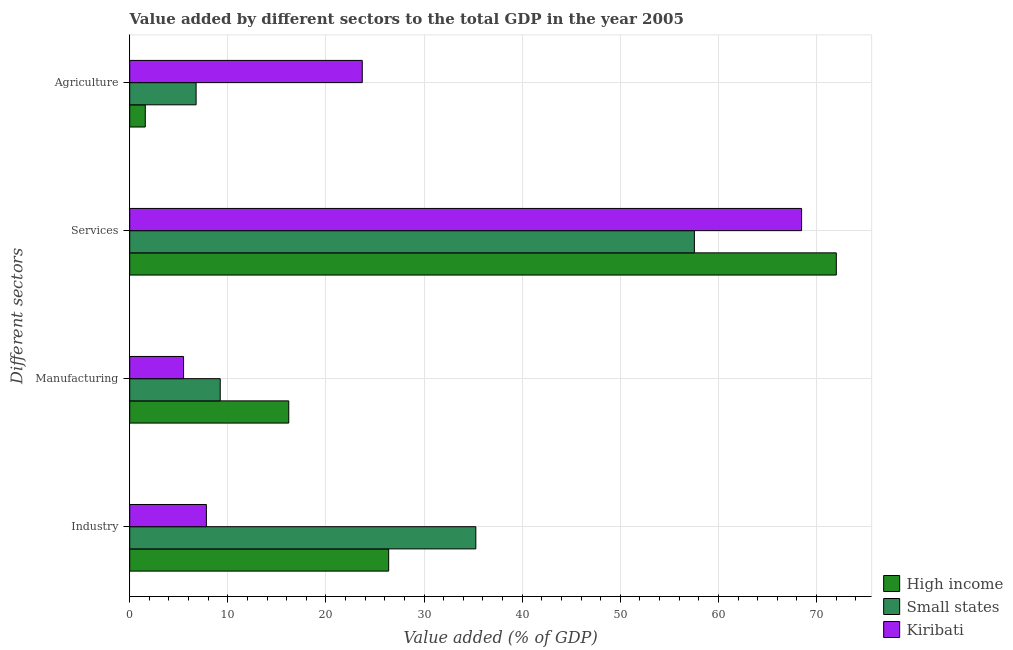How many different coloured bars are there?
Keep it short and to the point. 3. How many bars are there on the 3rd tick from the top?
Your response must be concise. 3. What is the label of the 1st group of bars from the top?
Make the answer very short. Agriculture. What is the value added by agricultural sector in Small states?
Give a very brief answer. 6.77. Across all countries, what is the maximum value added by industrial sector?
Keep it short and to the point. 35.28. Across all countries, what is the minimum value added by manufacturing sector?
Ensure brevity in your answer.  5.49. In which country was the value added by services sector maximum?
Give a very brief answer. High income. In which country was the value added by services sector minimum?
Provide a short and direct response. Small states. What is the total value added by agricultural sector in the graph?
Provide a succinct answer. 32.05. What is the difference between the value added by services sector in Kiribati and that in High income?
Your answer should be compact. -3.54. What is the difference between the value added by agricultural sector in Kiribati and the value added by services sector in High income?
Provide a succinct answer. -48.32. What is the average value added by industrial sector per country?
Provide a succinct answer. 23.16. What is the difference between the value added by services sector and value added by industrial sector in Kiribati?
Provide a short and direct response. 60.67. In how many countries, is the value added by services sector greater than 58 %?
Ensure brevity in your answer.  2. What is the ratio of the value added by industrial sector in Small states to that in Kiribati?
Offer a very short reply. 4.51. What is the difference between the highest and the second highest value added by services sector?
Make the answer very short. 3.54. What is the difference between the highest and the lowest value added by manufacturing sector?
Provide a succinct answer. 10.72. What does the 2nd bar from the top in Services represents?
Your answer should be compact. Small states. Is it the case that in every country, the sum of the value added by industrial sector and value added by manufacturing sector is greater than the value added by services sector?
Your answer should be very brief. No. How many bars are there?
Your answer should be very brief. 12. What is the difference between two consecutive major ticks on the X-axis?
Keep it short and to the point. 10. Does the graph contain grids?
Give a very brief answer. Yes. How many legend labels are there?
Your answer should be very brief. 3. What is the title of the graph?
Your answer should be compact. Value added by different sectors to the total GDP in the year 2005. Does "Ethiopia" appear as one of the legend labels in the graph?
Your answer should be very brief. No. What is the label or title of the X-axis?
Keep it short and to the point. Value added (% of GDP). What is the label or title of the Y-axis?
Keep it short and to the point. Different sectors. What is the Value added (% of GDP) in High income in Industry?
Provide a short and direct response. 26.39. What is the Value added (% of GDP) in Small states in Industry?
Provide a short and direct response. 35.28. What is the Value added (% of GDP) in Kiribati in Industry?
Your answer should be very brief. 7.81. What is the Value added (% of GDP) of High income in Manufacturing?
Your answer should be very brief. 16.21. What is the Value added (% of GDP) of Small states in Manufacturing?
Offer a terse response. 9.23. What is the Value added (% of GDP) in Kiribati in Manufacturing?
Your answer should be very brief. 5.49. What is the Value added (% of GDP) of High income in Services?
Your answer should be compact. 72.02. What is the Value added (% of GDP) in Small states in Services?
Offer a terse response. 57.55. What is the Value added (% of GDP) in Kiribati in Services?
Make the answer very short. 68.48. What is the Value added (% of GDP) of High income in Agriculture?
Provide a short and direct response. 1.59. What is the Value added (% of GDP) in Small states in Agriculture?
Offer a very short reply. 6.77. What is the Value added (% of GDP) of Kiribati in Agriculture?
Keep it short and to the point. 23.7. Across all Different sectors, what is the maximum Value added (% of GDP) of High income?
Offer a terse response. 72.02. Across all Different sectors, what is the maximum Value added (% of GDP) in Small states?
Ensure brevity in your answer.  57.55. Across all Different sectors, what is the maximum Value added (% of GDP) of Kiribati?
Your answer should be compact. 68.48. Across all Different sectors, what is the minimum Value added (% of GDP) in High income?
Your answer should be very brief. 1.59. Across all Different sectors, what is the minimum Value added (% of GDP) of Small states?
Provide a short and direct response. 6.77. Across all Different sectors, what is the minimum Value added (% of GDP) of Kiribati?
Ensure brevity in your answer.  5.49. What is the total Value added (% of GDP) in High income in the graph?
Provide a short and direct response. 116.21. What is the total Value added (% of GDP) of Small states in the graph?
Give a very brief answer. 108.82. What is the total Value added (% of GDP) of Kiribati in the graph?
Provide a short and direct response. 105.49. What is the difference between the Value added (% of GDP) in High income in Industry and that in Manufacturing?
Keep it short and to the point. 10.18. What is the difference between the Value added (% of GDP) of Small states in Industry and that in Manufacturing?
Your answer should be compact. 26.05. What is the difference between the Value added (% of GDP) of Kiribati in Industry and that in Manufacturing?
Offer a very short reply. 2.33. What is the difference between the Value added (% of GDP) of High income in Industry and that in Services?
Ensure brevity in your answer.  -45.63. What is the difference between the Value added (% of GDP) of Small states in Industry and that in Services?
Your answer should be compact. -22.28. What is the difference between the Value added (% of GDP) in Kiribati in Industry and that in Services?
Your answer should be compact. -60.67. What is the difference between the Value added (% of GDP) of High income in Industry and that in Agriculture?
Ensure brevity in your answer.  24.81. What is the difference between the Value added (% of GDP) in Small states in Industry and that in Agriculture?
Your answer should be very brief. 28.51. What is the difference between the Value added (% of GDP) in Kiribati in Industry and that in Agriculture?
Give a very brief answer. -15.89. What is the difference between the Value added (% of GDP) in High income in Manufacturing and that in Services?
Ensure brevity in your answer.  -55.81. What is the difference between the Value added (% of GDP) in Small states in Manufacturing and that in Services?
Make the answer very short. -48.33. What is the difference between the Value added (% of GDP) in Kiribati in Manufacturing and that in Services?
Provide a succinct answer. -63. What is the difference between the Value added (% of GDP) of High income in Manufacturing and that in Agriculture?
Provide a succinct answer. 14.62. What is the difference between the Value added (% of GDP) of Small states in Manufacturing and that in Agriculture?
Make the answer very short. 2.46. What is the difference between the Value added (% of GDP) of Kiribati in Manufacturing and that in Agriculture?
Your answer should be compact. -18.22. What is the difference between the Value added (% of GDP) of High income in Services and that in Agriculture?
Give a very brief answer. 70.44. What is the difference between the Value added (% of GDP) of Small states in Services and that in Agriculture?
Your response must be concise. 50.79. What is the difference between the Value added (% of GDP) in Kiribati in Services and that in Agriculture?
Offer a very short reply. 44.78. What is the difference between the Value added (% of GDP) in High income in Industry and the Value added (% of GDP) in Small states in Manufacturing?
Provide a succinct answer. 17.17. What is the difference between the Value added (% of GDP) of High income in Industry and the Value added (% of GDP) of Kiribati in Manufacturing?
Your response must be concise. 20.91. What is the difference between the Value added (% of GDP) in Small states in Industry and the Value added (% of GDP) in Kiribati in Manufacturing?
Provide a succinct answer. 29.79. What is the difference between the Value added (% of GDP) of High income in Industry and the Value added (% of GDP) of Small states in Services?
Make the answer very short. -31.16. What is the difference between the Value added (% of GDP) of High income in Industry and the Value added (% of GDP) of Kiribati in Services?
Make the answer very short. -42.09. What is the difference between the Value added (% of GDP) of Small states in Industry and the Value added (% of GDP) of Kiribati in Services?
Offer a very short reply. -33.2. What is the difference between the Value added (% of GDP) in High income in Industry and the Value added (% of GDP) in Small states in Agriculture?
Keep it short and to the point. 19.63. What is the difference between the Value added (% of GDP) in High income in Industry and the Value added (% of GDP) in Kiribati in Agriculture?
Provide a short and direct response. 2.69. What is the difference between the Value added (% of GDP) in Small states in Industry and the Value added (% of GDP) in Kiribati in Agriculture?
Provide a succinct answer. 11.58. What is the difference between the Value added (% of GDP) in High income in Manufacturing and the Value added (% of GDP) in Small states in Services?
Your response must be concise. -41.34. What is the difference between the Value added (% of GDP) in High income in Manufacturing and the Value added (% of GDP) in Kiribati in Services?
Offer a terse response. -52.27. What is the difference between the Value added (% of GDP) in Small states in Manufacturing and the Value added (% of GDP) in Kiribati in Services?
Your response must be concise. -59.26. What is the difference between the Value added (% of GDP) of High income in Manufacturing and the Value added (% of GDP) of Small states in Agriculture?
Give a very brief answer. 9.44. What is the difference between the Value added (% of GDP) of High income in Manufacturing and the Value added (% of GDP) of Kiribati in Agriculture?
Offer a terse response. -7.49. What is the difference between the Value added (% of GDP) in Small states in Manufacturing and the Value added (% of GDP) in Kiribati in Agriculture?
Offer a very short reply. -14.48. What is the difference between the Value added (% of GDP) of High income in Services and the Value added (% of GDP) of Small states in Agriculture?
Your response must be concise. 65.26. What is the difference between the Value added (% of GDP) of High income in Services and the Value added (% of GDP) of Kiribati in Agriculture?
Ensure brevity in your answer.  48.32. What is the difference between the Value added (% of GDP) of Small states in Services and the Value added (% of GDP) of Kiribati in Agriculture?
Your answer should be compact. 33.85. What is the average Value added (% of GDP) of High income per Different sectors?
Provide a short and direct response. 29.05. What is the average Value added (% of GDP) in Small states per Different sectors?
Offer a terse response. 27.21. What is the average Value added (% of GDP) of Kiribati per Different sectors?
Provide a succinct answer. 26.37. What is the difference between the Value added (% of GDP) of High income and Value added (% of GDP) of Small states in Industry?
Your response must be concise. -8.88. What is the difference between the Value added (% of GDP) in High income and Value added (% of GDP) in Kiribati in Industry?
Ensure brevity in your answer.  18.58. What is the difference between the Value added (% of GDP) in Small states and Value added (% of GDP) in Kiribati in Industry?
Keep it short and to the point. 27.46. What is the difference between the Value added (% of GDP) of High income and Value added (% of GDP) of Small states in Manufacturing?
Your answer should be very brief. 6.99. What is the difference between the Value added (% of GDP) of High income and Value added (% of GDP) of Kiribati in Manufacturing?
Your answer should be compact. 10.72. What is the difference between the Value added (% of GDP) of Small states and Value added (% of GDP) of Kiribati in Manufacturing?
Your answer should be compact. 3.74. What is the difference between the Value added (% of GDP) in High income and Value added (% of GDP) in Small states in Services?
Provide a short and direct response. 14.47. What is the difference between the Value added (% of GDP) in High income and Value added (% of GDP) in Kiribati in Services?
Provide a short and direct response. 3.54. What is the difference between the Value added (% of GDP) in Small states and Value added (% of GDP) in Kiribati in Services?
Offer a terse response. -10.93. What is the difference between the Value added (% of GDP) in High income and Value added (% of GDP) in Small states in Agriculture?
Offer a terse response. -5.18. What is the difference between the Value added (% of GDP) of High income and Value added (% of GDP) of Kiribati in Agriculture?
Your answer should be very brief. -22.12. What is the difference between the Value added (% of GDP) in Small states and Value added (% of GDP) in Kiribati in Agriculture?
Your answer should be compact. -16.94. What is the ratio of the Value added (% of GDP) in High income in Industry to that in Manufacturing?
Ensure brevity in your answer.  1.63. What is the ratio of the Value added (% of GDP) in Small states in Industry to that in Manufacturing?
Offer a terse response. 3.82. What is the ratio of the Value added (% of GDP) of Kiribati in Industry to that in Manufacturing?
Your answer should be compact. 1.42. What is the ratio of the Value added (% of GDP) of High income in Industry to that in Services?
Your response must be concise. 0.37. What is the ratio of the Value added (% of GDP) in Small states in Industry to that in Services?
Your response must be concise. 0.61. What is the ratio of the Value added (% of GDP) in Kiribati in Industry to that in Services?
Ensure brevity in your answer.  0.11. What is the ratio of the Value added (% of GDP) of High income in Industry to that in Agriculture?
Make the answer very short. 16.65. What is the ratio of the Value added (% of GDP) of Small states in Industry to that in Agriculture?
Your answer should be compact. 5.21. What is the ratio of the Value added (% of GDP) of Kiribati in Industry to that in Agriculture?
Keep it short and to the point. 0.33. What is the ratio of the Value added (% of GDP) in High income in Manufacturing to that in Services?
Offer a very short reply. 0.23. What is the ratio of the Value added (% of GDP) in Small states in Manufacturing to that in Services?
Your answer should be compact. 0.16. What is the ratio of the Value added (% of GDP) of Kiribati in Manufacturing to that in Services?
Ensure brevity in your answer.  0.08. What is the ratio of the Value added (% of GDP) of High income in Manufacturing to that in Agriculture?
Keep it short and to the point. 10.22. What is the ratio of the Value added (% of GDP) of Small states in Manufacturing to that in Agriculture?
Provide a succinct answer. 1.36. What is the ratio of the Value added (% of GDP) of Kiribati in Manufacturing to that in Agriculture?
Offer a terse response. 0.23. What is the ratio of the Value added (% of GDP) in High income in Services to that in Agriculture?
Make the answer very short. 45.42. What is the ratio of the Value added (% of GDP) in Small states in Services to that in Agriculture?
Ensure brevity in your answer.  8.51. What is the ratio of the Value added (% of GDP) in Kiribati in Services to that in Agriculture?
Keep it short and to the point. 2.89. What is the difference between the highest and the second highest Value added (% of GDP) of High income?
Provide a short and direct response. 45.63. What is the difference between the highest and the second highest Value added (% of GDP) in Small states?
Your answer should be compact. 22.28. What is the difference between the highest and the second highest Value added (% of GDP) in Kiribati?
Give a very brief answer. 44.78. What is the difference between the highest and the lowest Value added (% of GDP) in High income?
Your answer should be very brief. 70.44. What is the difference between the highest and the lowest Value added (% of GDP) in Small states?
Keep it short and to the point. 50.79. What is the difference between the highest and the lowest Value added (% of GDP) in Kiribati?
Give a very brief answer. 63. 